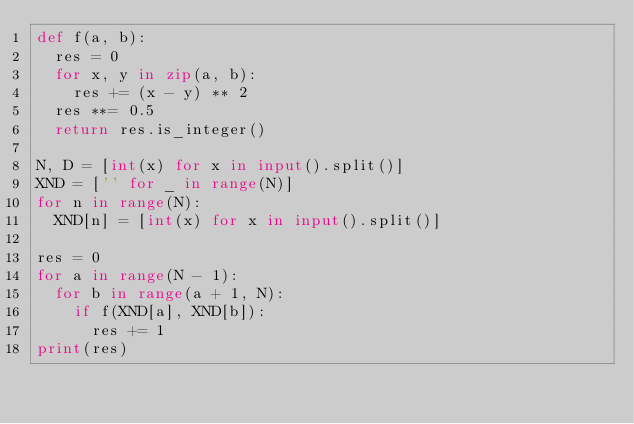Convert code to text. <code><loc_0><loc_0><loc_500><loc_500><_Python_>def f(a, b):
  res = 0
  for x, y in zip(a, b):
    res += (x - y) ** 2
  res **= 0.5
  return res.is_integer()
  
N, D = [int(x) for x in input().split()]
XND = ['' for _ in range(N)]
for n in range(N):
  XND[n] = [int(x) for x in input().split()]

res = 0
for a in range(N - 1):
  for b in range(a + 1, N):
    if f(XND[a], XND[b]):
      res += 1
print(res)</code> 